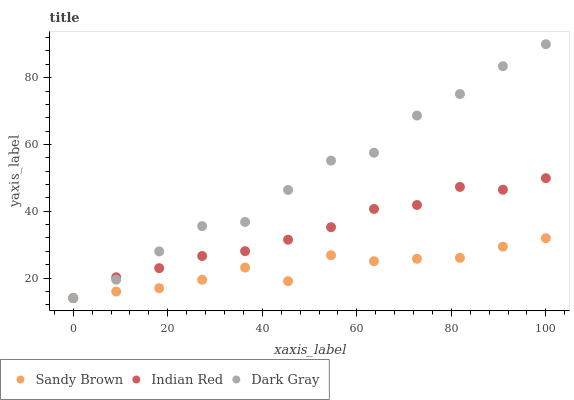Does Sandy Brown have the minimum area under the curve?
Answer yes or no. Yes. Does Dark Gray have the maximum area under the curve?
Answer yes or no. Yes. Does Indian Red have the minimum area under the curve?
Answer yes or no. No. Does Indian Red have the maximum area under the curve?
Answer yes or no. No. Is Indian Red the smoothest?
Answer yes or no. Yes. Is Dark Gray the roughest?
Answer yes or no. Yes. Is Sandy Brown the smoothest?
Answer yes or no. No. Is Sandy Brown the roughest?
Answer yes or no. No. Does Dark Gray have the lowest value?
Answer yes or no. Yes. Does Dark Gray have the highest value?
Answer yes or no. Yes. Does Indian Red have the highest value?
Answer yes or no. No. Does Indian Red intersect Sandy Brown?
Answer yes or no. Yes. Is Indian Red less than Sandy Brown?
Answer yes or no. No. Is Indian Red greater than Sandy Brown?
Answer yes or no. No. 